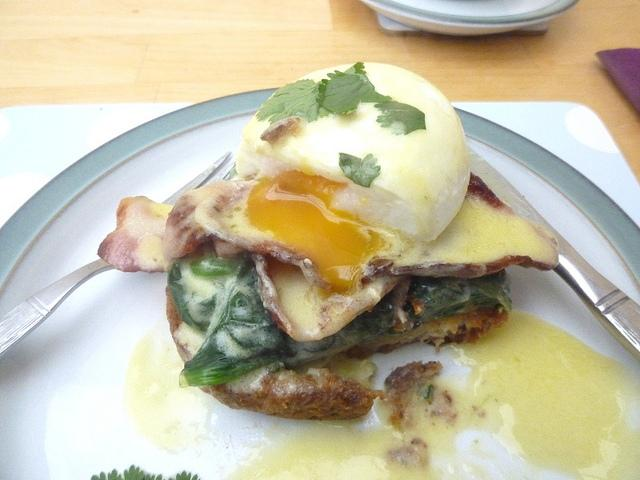What is near the top of the food pile? Please explain your reasoning. egg. An egg is on top 